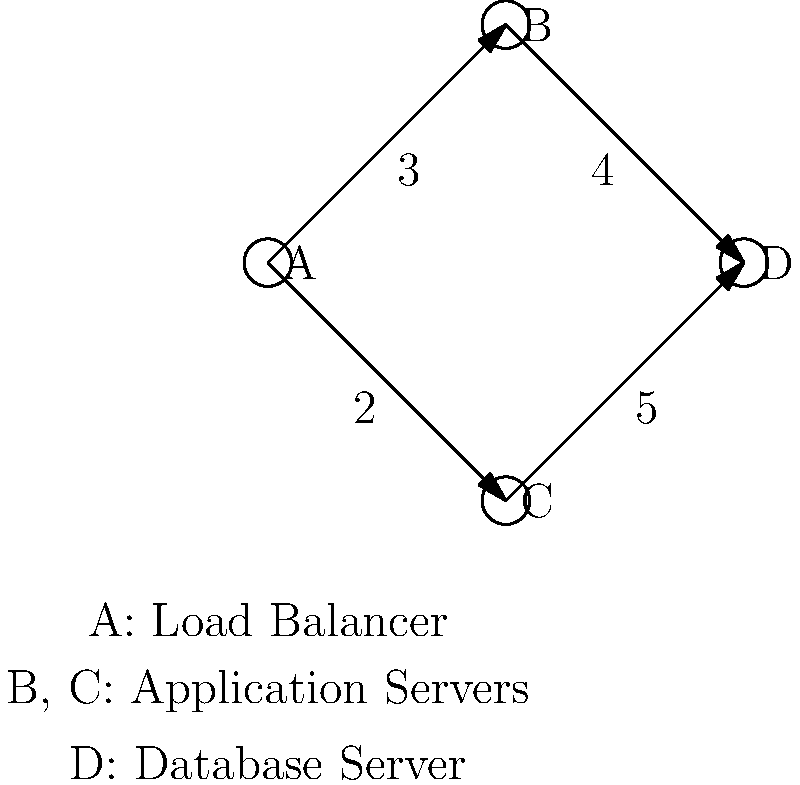In a Docker environment, a load balancer (A) distributes traffic to two application servers (B and C), which then connect to a database server (D). The weighted graph represents the network latency (in milliseconds) between the components. What is the total latency for a request that goes through the path with the least overall latency from A to D? To find the path with the least overall latency from A to D, we need to consider all possible paths and their total latencies:

1. Path A -> B -> D:
   - Latency from A to B: 3 ms
   - Latency from B to D: 4 ms
   - Total latency: 3 + 4 = 7 ms

2. Path A -> C -> D:
   - Latency from A to C: 2 ms
   - Latency from C to D: 5 ms
   - Total latency: 2 + 5 = 7 ms

Both paths have the same total latency of 7 ms. Since the question asks for the path with the least overall latency, we can choose either path.

The total latency for a request that goes through the path with the least overall latency from A to D is 7 ms.
Answer: 7 ms 